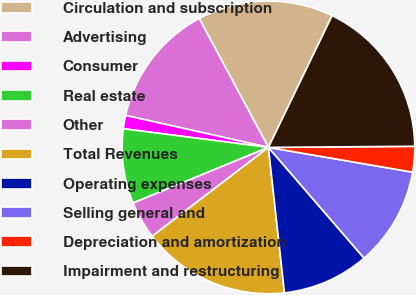<chart> <loc_0><loc_0><loc_500><loc_500><pie_chart><fcel>Circulation and subscription<fcel>Advertising<fcel>Consumer<fcel>Real estate<fcel>Other<fcel>Total Revenues<fcel>Operating expenses<fcel>Selling general and<fcel>Depreciation and amortization<fcel>Impairment and restructuring<nl><fcel>15.01%<fcel>13.65%<fcel>1.47%<fcel>8.24%<fcel>4.18%<fcel>16.36%<fcel>9.59%<fcel>10.95%<fcel>2.83%<fcel>17.71%<nl></chart> 